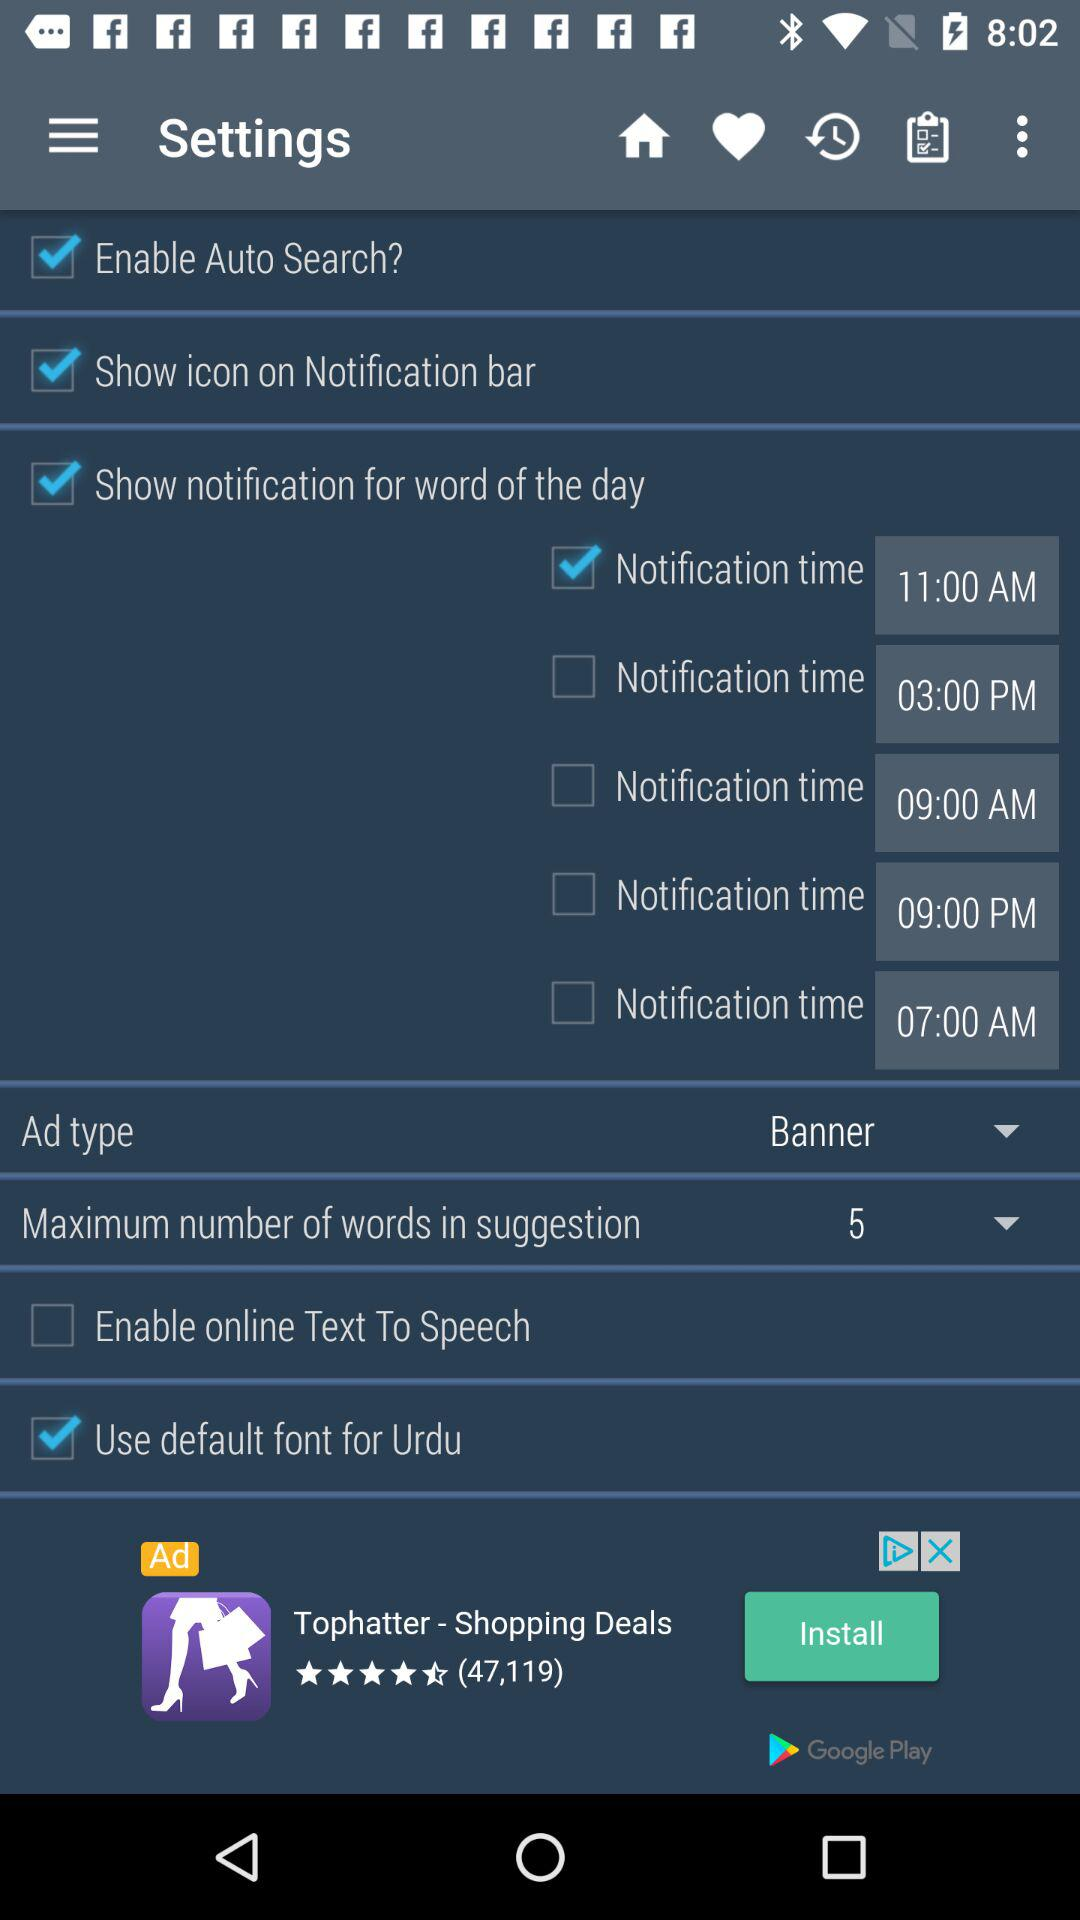How many notification times are there?
Answer the question using a single word or phrase. 5 